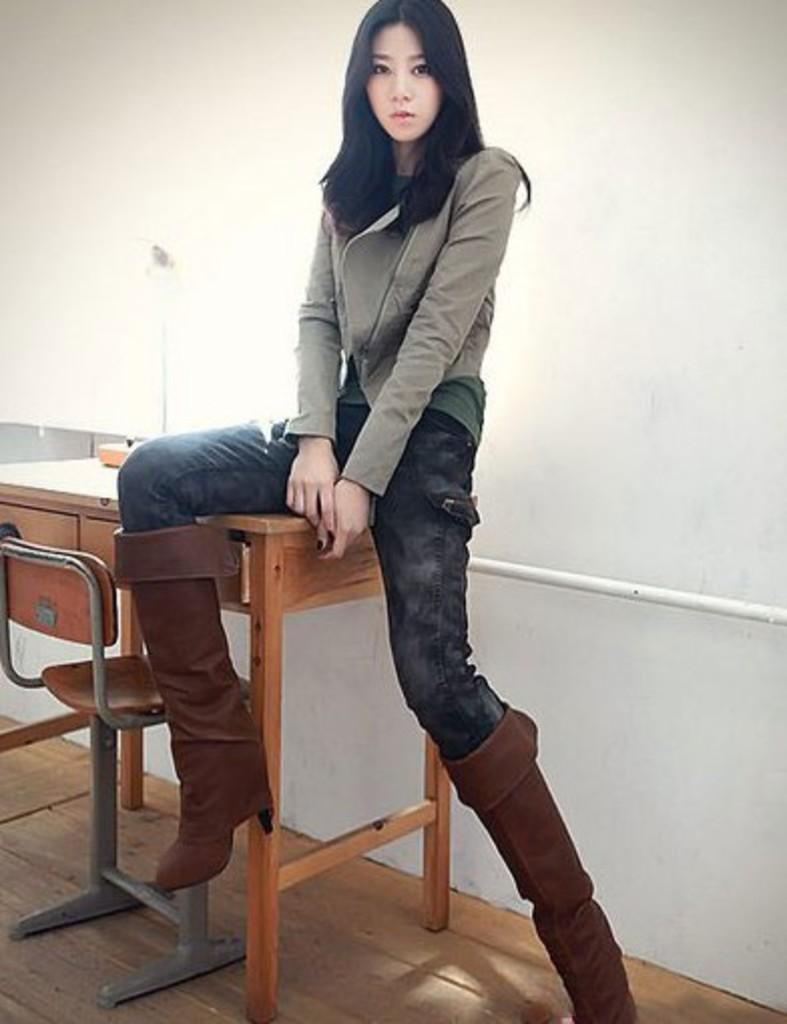What is the woman in the image doing? The woman is sitting on a bench in the image. What is located in front of the bench? There is a chair in front of the bench. What can be seen in the background of the image? There is a wall in the background of the image. What type of curtain is hanging from the beam in the image? There is no curtain or beam present in the image. 